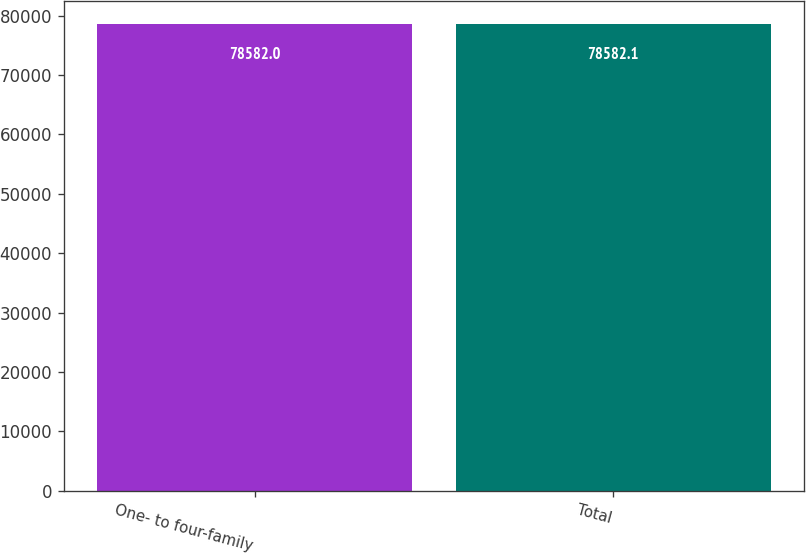Convert chart to OTSL. <chart><loc_0><loc_0><loc_500><loc_500><bar_chart><fcel>One- to four-family<fcel>Total<nl><fcel>78582<fcel>78582.1<nl></chart> 